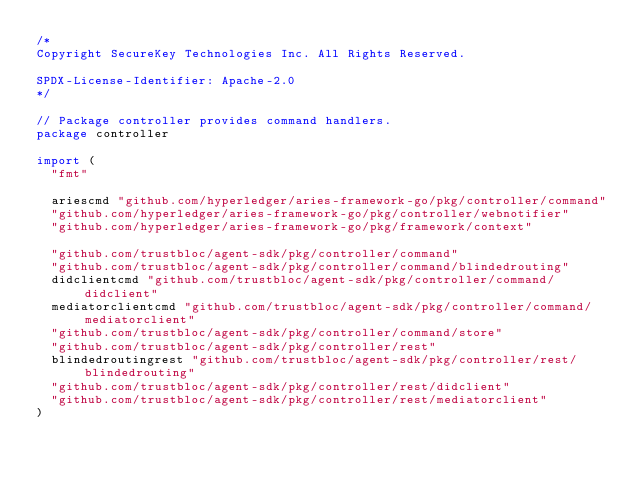<code> <loc_0><loc_0><loc_500><loc_500><_Go_>/*
Copyright SecureKey Technologies Inc. All Rights Reserved.

SPDX-License-Identifier: Apache-2.0
*/

// Package controller provides command handlers.
package controller

import (
	"fmt"

	ariescmd "github.com/hyperledger/aries-framework-go/pkg/controller/command"
	"github.com/hyperledger/aries-framework-go/pkg/controller/webnotifier"
	"github.com/hyperledger/aries-framework-go/pkg/framework/context"

	"github.com/trustbloc/agent-sdk/pkg/controller/command"
	"github.com/trustbloc/agent-sdk/pkg/controller/command/blindedrouting"
	didclientcmd "github.com/trustbloc/agent-sdk/pkg/controller/command/didclient"
	mediatorclientcmd "github.com/trustbloc/agent-sdk/pkg/controller/command/mediatorclient"
	"github.com/trustbloc/agent-sdk/pkg/controller/command/store"
	"github.com/trustbloc/agent-sdk/pkg/controller/rest"
	blindedroutingrest "github.com/trustbloc/agent-sdk/pkg/controller/rest/blindedrouting"
	"github.com/trustbloc/agent-sdk/pkg/controller/rest/didclient"
	"github.com/trustbloc/agent-sdk/pkg/controller/rest/mediatorclient"
)
</code> 